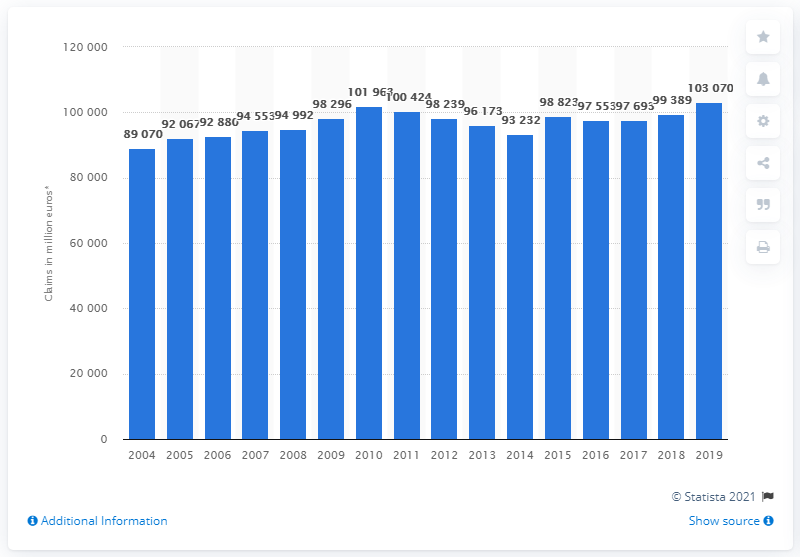Specify some key components in this picture. The total worth of motor insurance claims paid out by insurance providers in Europe from 2004 to 2019 was approximately 103,070 million euros. 